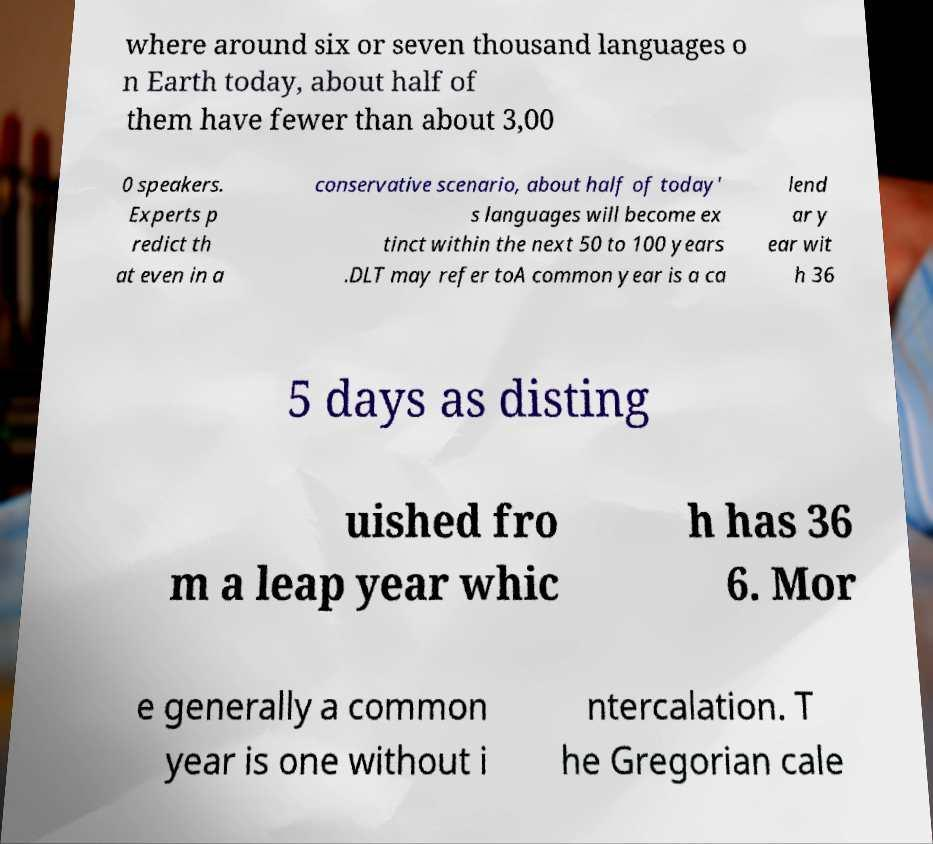For documentation purposes, I need the text within this image transcribed. Could you provide that? where around six or seven thousand languages o n Earth today, about half of them have fewer than about 3,00 0 speakers. Experts p redict th at even in a conservative scenario, about half of today' s languages will become ex tinct within the next 50 to 100 years .DLT may refer toA common year is a ca lend ar y ear wit h 36 5 days as disting uished fro m a leap year whic h has 36 6. Mor e generally a common year is one without i ntercalation. T he Gregorian cale 